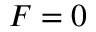Convert formula to latex. <formula><loc_0><loc_0><loc_500><loc_500>F = 0</formula> 